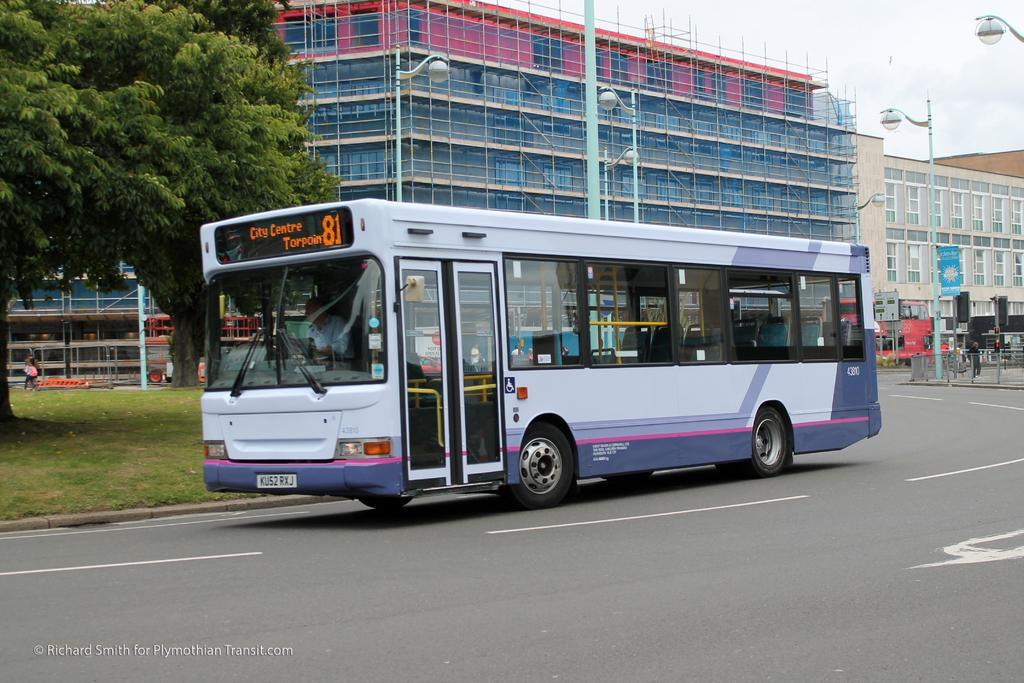<image>
Provide a brief description of the given image. A city bus is displaying City Centre Torpoin 81 in the window. 